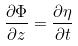Convert formula to latex. <formula><loc_0><loc_0><loc_500><loc_500>\frac { \partial \Phi } { \partial z } = \frac { \partial \eta } { \partial t }</formula> 